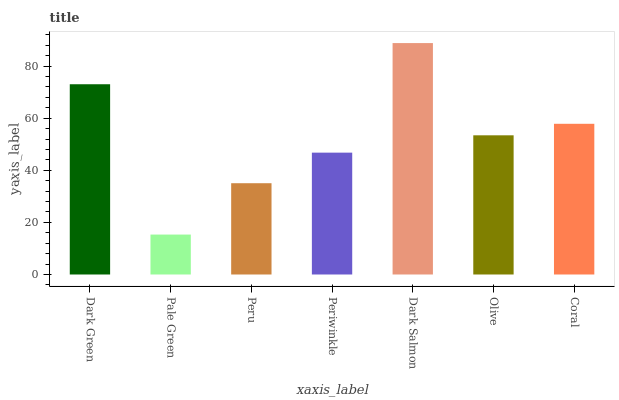Is Pale Green the minimum?
Answer yes or no. Yes. Is Dark Salmon the maximum?
Answer yes or no. Yes. Is Peru the minimum?
Answer yes or no. No. Is Peru the maximum?
Answer yes or no. No. Is Peru greater than Pale Green?
Answer yes or no. Yes. Is Pale Green less than Peru?
Answer yes or no. Yes. Is Pale Green greater than Peru?
Answer yes or no. No. Is Peru less than Pale Green?
Answer yes or no. No. Is Olive the high median?
Answer yes or no. Yes. Is Olive the low median?
Answer yes or no. Yes. Is Pale Green the high median?
Answer yes or no. No. Is Dark Salmon the low median?
Answer yes or no. No. 